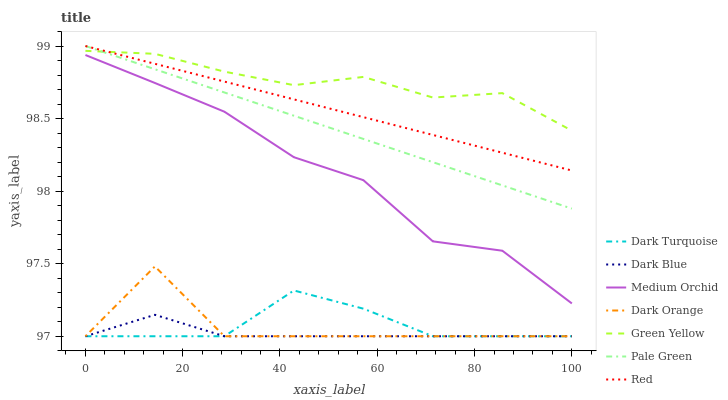Does Dark Blue have the minimum area under the curve?
Answer yes or no. Yes. Does Green Yellow have the maximum area under the curve?
Answer yes or no. Yes. Does Dark Turquoise have the minimum area under the curve?
Answer yes or no. No. Does Dark Turquoise have the maximum area under the curve?
Answer yes or no. No. Is Pale Green the smoothest?
Answer yes or no. Yes. Is Dark Orange the roughest?
Answer yes or no. Yes. Is Dark Turquoise the smoothest?
Answer yes or no. No. Is Dark Turquoise the roughest?
Answer yes or no. No. Does Dark Orange have the lowest value?
Answer yes or no. Yes. Does Medium Orchid have the lowest value?
Answer yes or no. No. Does Red have the highest value?
Answer yes or no. Yes. Does Dark Turquoise have the highest value?
Answer yes or no. No. Is Medium Orchid less than Green Yellow?
Answer yes or no. Yes. Is Red greater than Dark Orange?
Answer yes or no. Yes. Does Pale Green intersect Red?
Answer yes or no. Yes. Is Pale Green less than Red?
Answer yes or no. No. Is Pale Green greater than Red?
Answer yes or no. No. Does Medium Orchid intersect Green Yellow?
Answer yes or no. No. 